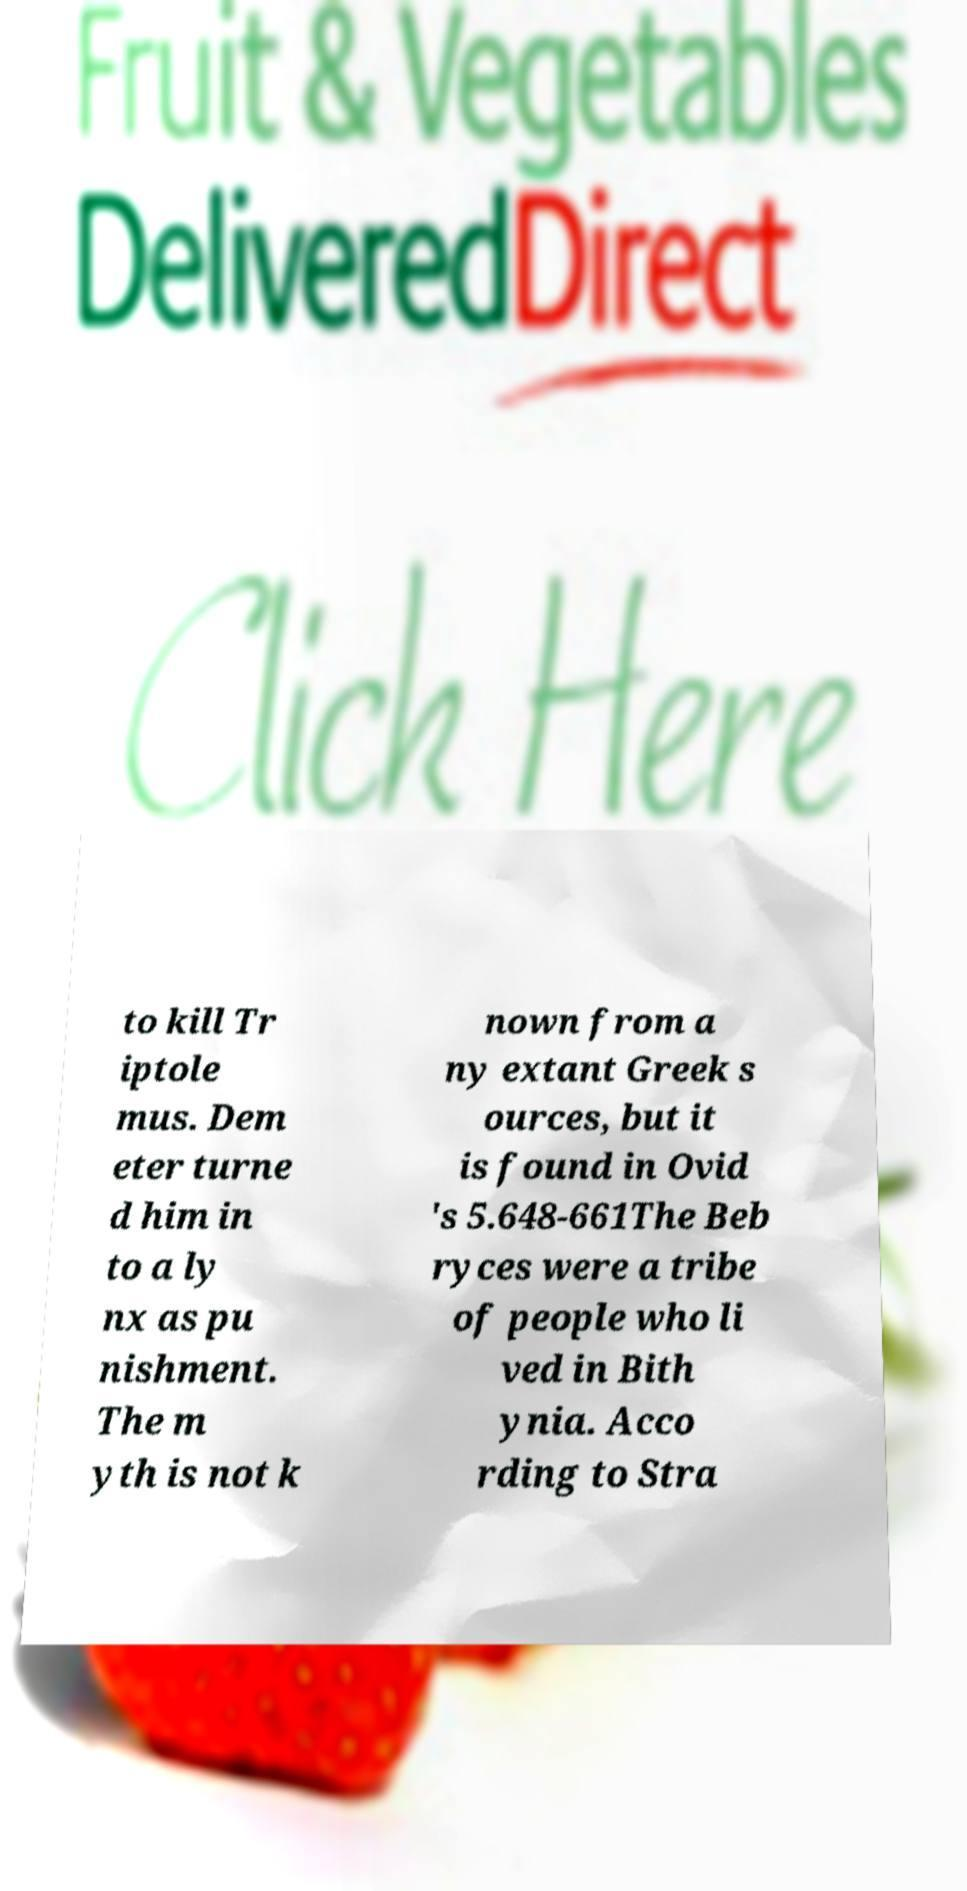Could you extract and type out the text from this image? to kill Tr iptole mus. Dem eter turne d him in to a ly nx as pu nishment. The m yth is not k nown from a ny extant Greek s ources, but it is found in Ovid 's 5.648-661The Beb ryces were a tribe of people who li ved in Bith ynia. Acco rding to Stra 